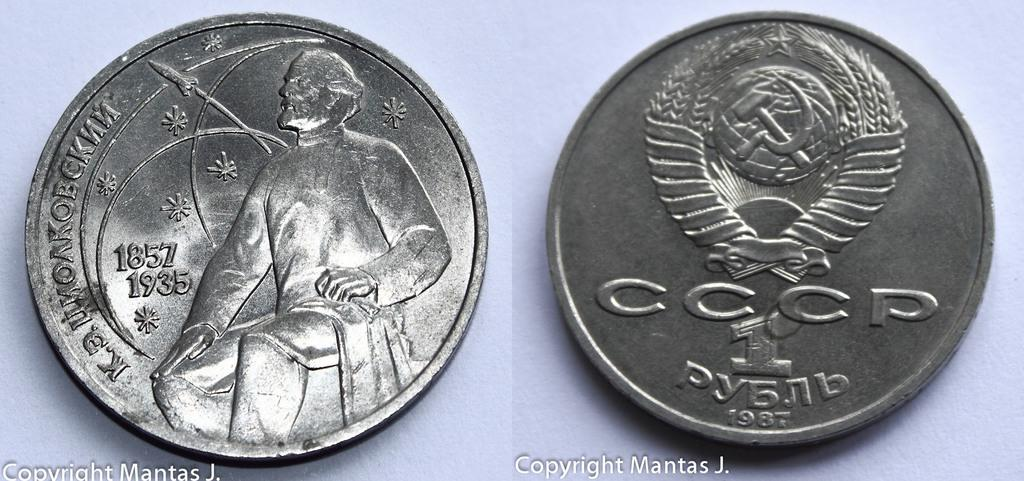What is the composition of the image? The image is a collage of two images. What objects can be seen in the picture? There are two coins in the picture. What type of request can be seen in the image? There is no request present in the image; it only contains a collage of two images and two coins. 